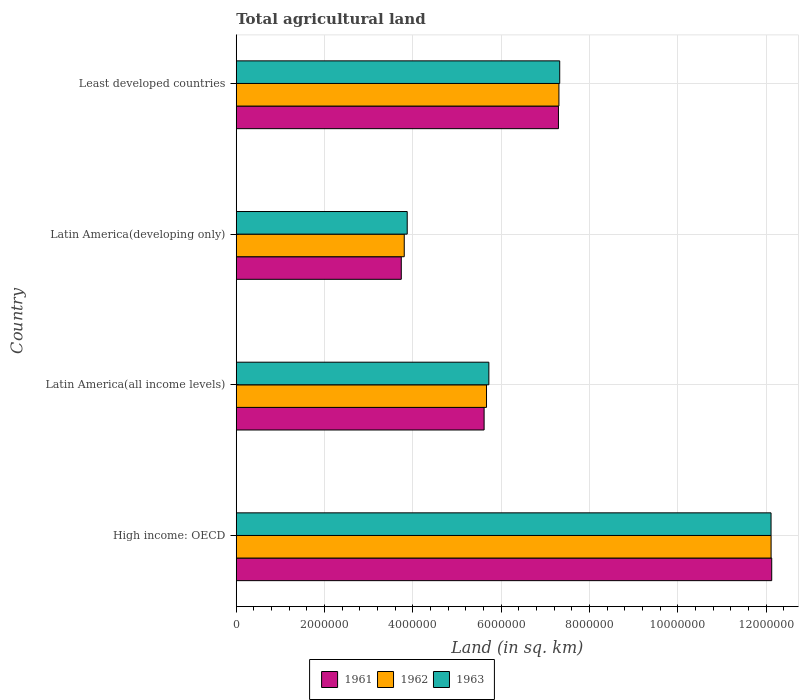How many different coloured bars are there?
Provide a succinct answer. 3. How many bars are there on the 2nd tick from the top?
Ensure brevity in your answer.  3. What is the label of the 1st group of bars from the top?
Provide a short and direct response. Least developed countries. In how many cases, is the number of bars for a given country not equal to the number of legend labels?
Give a very brief answer. 0. What is the total agricultural land in 1963 in Least developed countries?
Your response must be concise. 7.33e+06. Across all countries, what is the maximum total agricultural land in 1961?
Make the answer very short. 1.21e+07. Across all countries, what is the minimum total agricultural land in 1961?
Give a very brief answer. 3.74e+06. In which country was the total agricultural land in 1962 maximum?
Make the answer very short. High income: OECD. In which country was the total agricultural land in 1962 minimum?
Provide a succinct answer. Latin America(developing only). What is the total total agricultural land in 1961 in the graph?
Your answer should be very brief. 2.88e+07. What is the difference between the total agricultural land in 1963 in Latin America(all income levels) and that in Least developed countries?
Ensure brevity in your answer.  -1.60e+06. What is the difference between the total agricultural land in 1961 in High income: OECD and the total agricultural land in 1963 in Latin America(all income levels)?
Offer a terse response. 6.41e+06. What is the average total agricultural land in 1961 per country?
Provide a short and direct response. 7.19e+06. What is the difference between the total agricultural land in 1963 and total agricultural land in 1961 in Least developed countries?
Offer a terse response. 2.85e+04. What is the ratio of the total agricultural land in 1962 in High income: OECD to that in Latin America(all income levels)?
Make the answer very short. 2.14. What is the difference between the highest and the second highest total agricultural land in 1963?
Your response must be concise. 4.79e+06. What is the difference between the highest and the lowest total agricultural land in 1963?
Your answer should be compact. 8.24e+06. How many bars are there?
Offer a very short reply. 12. Where does the legend appear in the graph?
Keep it short and to the point. Bottom center. How are the legend labels stacked?
Give a very brief answer. Horizontal. What is the title of the graph?
Offer a very short reply. Total agricultural land. Does "1965" appear as one of the legend labels in the graph?
Your response must be concise. No. What is the label or title of the X-axis?
Offer a terse response. Land (in sq. km). What is the label or title of the Y-axis?
Make the answer very short. Country. What is the Land (in sq. km) in 1961 in High income: OECD?
Your response must be concise. 1.21e+07. What is the Land (in sq. km) of 1962 in High income: OECD?
Your answer should be very brief. 1.21e+07. What is the Land (in sq. km) of 1963 in High income: OECD?
Make the answer very short. 1.21e+07. What is the Land (in sq. km) of 1961 in Latin America(all income levels)?
Offer a very short reply. 5.61e+06. What is the Land (in sq. km) of 1962 in Latin America(all income levels)?
Your response must be concise. 5.67e+06. What is the Land (in sq. km) in 1963 in Latin America(all income levels)?
Your answer should be compact. 5.72e+06. What is the Land (in sq. km) in 1961 in Latin America(developing only)?
Your response must be concise. 3.74e+06. What is the Land (in sq. km) of 1962 in Latin America(developing only)?
Offer a very short reply. 3.80e+06. What is the Land (in sq. km) of 1963 in Latin America(developing only)?
Your answer should be very brief. 3.87e+06. What is the Land (in sq. km) in 1961 in Least developed countries?
Give a very brief answer. 7.30e+06. What is the Land (in sq. km) in 1962 in Least developed countries?
Your answer should be very brief. 7.31e+06. What is the Land (in sq. km) in 1963 in Least developed countries?
Your response must be concise. 7.33e+06. Across all countries, what is the maximum Land (in sq. km) of 1961?
Provide a succinct answer. 1.21e+07. Across all countries, what is the maximum Land (in sq. km) of 1962?
Provide a short and direct response. 1.21e+07. Across all countries, what is the maximum Land (in sq. km) in 1963?
Your answer should be very brief. 1.21e+07. Across all countries, what is the minimum Land (in sq. km) in 1961?
Your answer should be compact. 3.74e+06. Across all countries, what is the minimum Land (in sq. km) in 1962?
Your response must be concise. 3.80e+06. Across all countries, what is the minimum Land (in sq. km) of 1963?
Provide a succinct answer. 3.87e+06. What is the total Land (in sq. km) of 1961 in the graph?
Ensure brevity in your answer.  2.88e+07. What is the total Land (in sq. km) of 1962 in the graph?
Make the answer very short. 2.89e+07. What is the total Land (in sq. km) in 1963 in the graph?
Provide a short and direct response. 2.90e+07. What is the difference between the Land (in sq. km) in 1961 in High income: OECD and that in Latin America(all income levels)?
Keep it short and to the point. 6.51e+06. What is the difference between the Land (in sq. km) of 1962 in High income: OECD and that in Latin America(all income levels)?
Provide a succinct answer. 6.44e+06. What is the difference between the Land (in sq. km) of 1963 in High income: OECD and that in Latin America(all income levels)?
Your answer should be compact. 6.39e+06. What is the difference between the Land (in sq. km) of 1961 in High income: OECD and that in Latin America(developing only)?
Offer a terse response. 8.39e+06. What is the difference between the Land (in sq. km) of 1962 in High income: OECD and that in Latin America(developing only)?
Make the answer very short. 8.31e+06. What is the difference between the Land (in sq. km) in 1963 in High income: OECD and that in Latin America(developing only)?
Make the answer very short. 8.24e+06. What is the difference between the Land (in sq. km) in 1961 in High income: OECD and that in Least developed countries?
Offer a very short reply. 4.83e+06. What is the difference between the Land (in sq. km) of 1962 in High income: OECD and that in Least developed countries?
Ensure brevity in your answer.  4.81e+06. What is the difference between the Land (in sq. km) of 1963 in High income: OECD and that in Least developed countries?
Offer a terse response. 4.79e+06. What is the difference between the Land (in sq. km) of 1961 in Latin America(all income levels) and that in Latin America(developing only)?
Keep it short and to the point. 1.88e+06. What is the difference between the Land (in sq. km) in 1962 in Latin America(all income levels) and that in Latin America(developing only)?
Your response must be concise. 1.86e+06. What is the difference between the Land (in sq. km) of 1963 in Latin America(all income levels) and that in Latin America(developing only)?
Keep it short and to the point. 1.85e+06. What is the difference between the Land (in sq. km) of 1961 in Latin America(all income levels) and that in Least developed countries?
Your answer should be compact. -1.68e+06. What is the difference between the Land (in sq. km) of 1962 in Latin America(all income levels) and that in Least developed countries?
Your answer should be compact. -1.64e+06. What is the difference between the Land (in sq. km) in 1963 in Latin America(all income levels) and that in Least developed countries?
Provide a succinct answer. -1.60e+06. What is the difference between the Land (in sq. km) in 1961 in Latin America(developing only) and that in Least developed countries?
Your answer should be compact. -3.56e+06. What is the difference between the Land (in sq. km) in 1962 in Latin America(developing only) and that in Least developed countries?
Provide a short and direct response. -3.50e+06. What is the difference between the Land (in sq. km) in 1963 in Latin America(developing only) and that in Least developed countries?
Your response must be concise. -3.45e+06. What is the difference between the Land (in sq. km) of 1961 in High income: OECD and the Land (in sq. km) of 1962 in Latin America(all income levels)?
Ensure brevity in your answer.  6.46e+06. What is the difference between the Land (in sq. km) in 1961 in High income: OECD and the Land (in sq. km) in 1963 in Latin America(all income levels)?
Provide a short and direct response. 6.41e+06. What is the difference between the Land (in sq. km) of 1962 in High income: OECD and the Land (in sq. km) of 1963 in Latin America(all income levels)?
Make the answer very short. 6.39e+06. What is the difference between the Land (in sq. km) in 1961 in High income: OECD and the Land (in sq. km) in 1962 in Latin America(developing only)?
Your response must be concise. 8.32e+06. What is the difference between the Land (in sq. km) in 1961 in High income: OECD and the Land (in sq. km) in 1963 in Latin America(developing only)?
Offer a very short reply. 8.26e+06. What is the difference between the Land (in sq. km) of 1962 in High income: OECD and the Land (in sq. km) of 1963 in Latin America(developing only)?
Provide a succinct answer. 8.24e+06. What is the difference between the Land (in sq. km) in 1961 in High income: OECD and the Land (in sq. km) in 1962 in Least developed countries?
Make the answer very short. 4.82e+06. What is the difference between the Land (in sq. km) in 1961 in High income: OECD and the Land (in sq. km) in 1963 in Least developed countries?
Offer a terse response. 4.80e+06. What is the difference between the Land (in sq. km) of 1962 in High income: OECD and the Land (in sq. km) of 1963 in Least developed countries?
Ensure brevity in your answer.  4.79e+06. What is the difference between the Land (in sq. km) of 1961 in Latin America(all income levels) and the Land (in sq. km) of 1962 in Latin America(developing only)?
Your answer should be very brief. 1.81e+06. What is the difference between the Land (in sq. km) of 1961 in Latin America(all income levels) and the Land (in sq. km) of 1963 in Latin America(developing only)?
Provide a succinct answer. 1.74e+06. What is the difference between the Land (in sq. km) of 1962 in Latin America(all income levels) and the Land (in sq. km) of 1963 in Latin America(developing only)?
Ensure brevity in your answer.  1.80e+06. What is the difference between the Land (in sq. km) of 1961 in Latin America(all income levels) and the Land (in sq. km) of 1962 in Least developed countries?
Provide a succinct answer. -1.69e+06. What is the difference between the Land (in sq. km) in 1961 in Latin America(all income levels) and the Land (in sq. km) in 1963 in Least developed countries?
Offer a very short reply. -1.71e+06. What is the difference between the Land (in sq. km) of 1962 in Latin America(all income levels) and the Land (in sq. km) of 1963 in Least developed countries?
Make the answer very short. -1.66e+06. What is the difference between the Land (in sq. km) in 1961 in Latin America(developing only) and the Land (in sq. km) in 1962 in Least developed countries?
Offer a terse response. -3.57e+06. What is the difference between the Land (in sq. km) in 1961 in Latin America(developing only) and the Land (in sq. km) in 1963 in Least developed countries?
Your answer should be compact. -3.59e+06. What is the difference between the Land (in sq. km) of 1962 in Latin America(developing only) and the Land (in sq. km) of 1963 in Least developed countries?
Offer a very short reply. -3.52e+06. What is the average Land (in sq. km) of 1961 per country?
Your answer should be compact. 7.19e+06. What is the average Land (in sq. km) in 1962 per country?
Ensure brevity in your answer.  7.22e+06. What is the average Land (in sq. km) of 1963 per country?
Offer a very short reply. 7.26e+06. What is the difference between the Land (in sq. km) of 1961 and Land (in sq. km) of 1962 in High income: OECD?
Provide a succinct answer. 1.41e+04. What is the difference between the Land (in sq. km) in 1961 and Land (in sq. km) in 1963 in High income: OECD?
Your answer should be very brief. 1.52e+04. What is the difference between the Land (in sq. km) of 1962 and Land (in sq. km) of 1963 in High income: OECD?
Give a very brief answer. 1028. What is the difference between the Land (in sq. km) of 1961 and Land (in sq. km) of 1962 in Latin America(all income levels)?
Offer a terse response. -5.45e+04. What is the difference between the Land (in sq. km) in 1961 and Land (in sq. km) in 1963 in Latin America(all income levels)?
Ensure brevity in your answer.  -1.07e+05. What is the difference between the Land (in sq. km) in 1962 and Land (in sq. km) in 1963 in Latin America(all income levels)?
Provide a short and direct response. -5.29e+04. What is the difference between the Land (in sq. km) of 1961 and Land (in sq. km) of 1962 in Latin America(developing only)?
Give a very brief answer. -6.73e+04. What is the difference between the Land (in sq. km) of 1961 and Land (in sq. km) of 1963 in Latin America(developing only)?
Provide a succinct answer. -1.34e+05. What is the difference between the Land (in sq. km) in 1962 and Land (in sq. km) in 1963 in Latin America(developing only)?
Make the answer very short. -6.71e+04. What is the difference between the Land (in sq. km) in 1961 and Land (in sq. km) in 1962 in Least developed countries?
Make the answer very short. -1.06e+04. What is the difference between the Land (in sq. km) in 1961 and Land (in sq. km) in 1963 in Least developed countries?
Make the answer very short. -2.85e+04. What is the difference between the Land (in sq. km) of 1962 and Land (in sq. km) of 1963 in Least developed countries?
Give a very brief answer. -1.80e+04. What is the ratio of the Land (in sq. km) of 1961 in High income: OECD to that in Latin America(all income levels)?
Ensure brevity in your answer.  2.16. What is the ratio of the Land (in sq. km) of 1962 in High income: OECD to that in Latin America(all income levels)?
Ensure brevity in your answer.  2.14. What is the ratio of the Land (in sq. km) of 1963 in High income: OECD to that in Latin America(all income levels)?
Give a very brief answer. 2.12. What is the ratio of the Land (in sq. km) of 1961 in High income: OECD to that in Latin America(developing only)?
Provide a succinct answer. 3.24. What is the ratio of the Land (in sq. km) in 1962 in High income: OECD to that in Latin America(developing only)?
Ensure brevity in your answer.  3.18. What is the ratio of the Land (in sq. km) of 1963 in High income: OECD to that in Latin America(developing only)?
Give a very brief answer. 3.13. What is the ratio of the Land (in sq. km) of 1961 in High income: OECD to that in Least developed countries?
Your response must be concise. 1.66. What is the ratio of the Land (in sq. km) in 1962 in High income: OECD to that in Least developed countries?
Keep it short and to the point. 1.66. What is the ratio of the Land (in sq. km) in 1963 in High income: OECD to that in Least developed countries?
Keep it short and to the point. 1.65. What is the ratio of the Land (in sq. km) in 1961 in Latin America(all income levels) to that in Latin America(developing only)?
Your answer should be compact. 1.5. What is the ratio of the Land (in sq. km) in 1962 in Latin America(all income levels) to that in Latin America(developing only)?
Your answer should be compact. 1.49. What is the ratio of the Land (in sq. km) of 1963 in Latin America(all income levels) to that in Latin America(developing only)?
Your answer should be compact. 1.48. What is the ratio of the Land (in sq. km) of 1961 in Latin America(all income levels) to that in Least developed countries?
Offer a very short reply. 0.77. What is the ratio of the Land (in sq. km) in 1962 in Latin America(all income levels) to that in Least developed countries?
Your answer should be compact. 0.78. What is the ratio of the Land (in sq. km) in 1963 in Latin America(all income levels) to that in Least developed countries?
Provide a succinct answer. 0.78. What is the ratio of the Land (in sq. km) of 1961 in Latin America(developing only) to that in Least developed countries?
Offer a terse response. 0.51. What is the ratio of the Land (in sq. km) in 1962 in Latin America(developing only) to that in Least developed countries?
Offer a very short reply. 0.52. What is the ratio of the Land (in sq. km) in 1963 in Latin America(developing only) to that in Least developed countries?
Offer a very short reply. 0.53. What is the difference between the highest and the second highest Land (in sq. km) in 1961?
Your response must be concise. 4.83e+06. What is the difference between the highest and the second highest Land (in sq. km) in 1962?
Offer a very short reply. 4.81e+06. What is the difference between the highest and the second highest Land (in sq. km) of 1963?
Keep it short and to the point. 4.79e+06. What is the difference between the highest and the lowest Land (in sq. km) of 1961?
Your answer should be very brief. 8.39e+06. What is the difference between the highest and the lowest Land (in sq. km) of 1962?
Provide a succinct answer. 8.31e+06. What is the difference between the highest and the lowest Land (in sq. km) of 1963?
Your answer should be compact. 8.24e+06. 